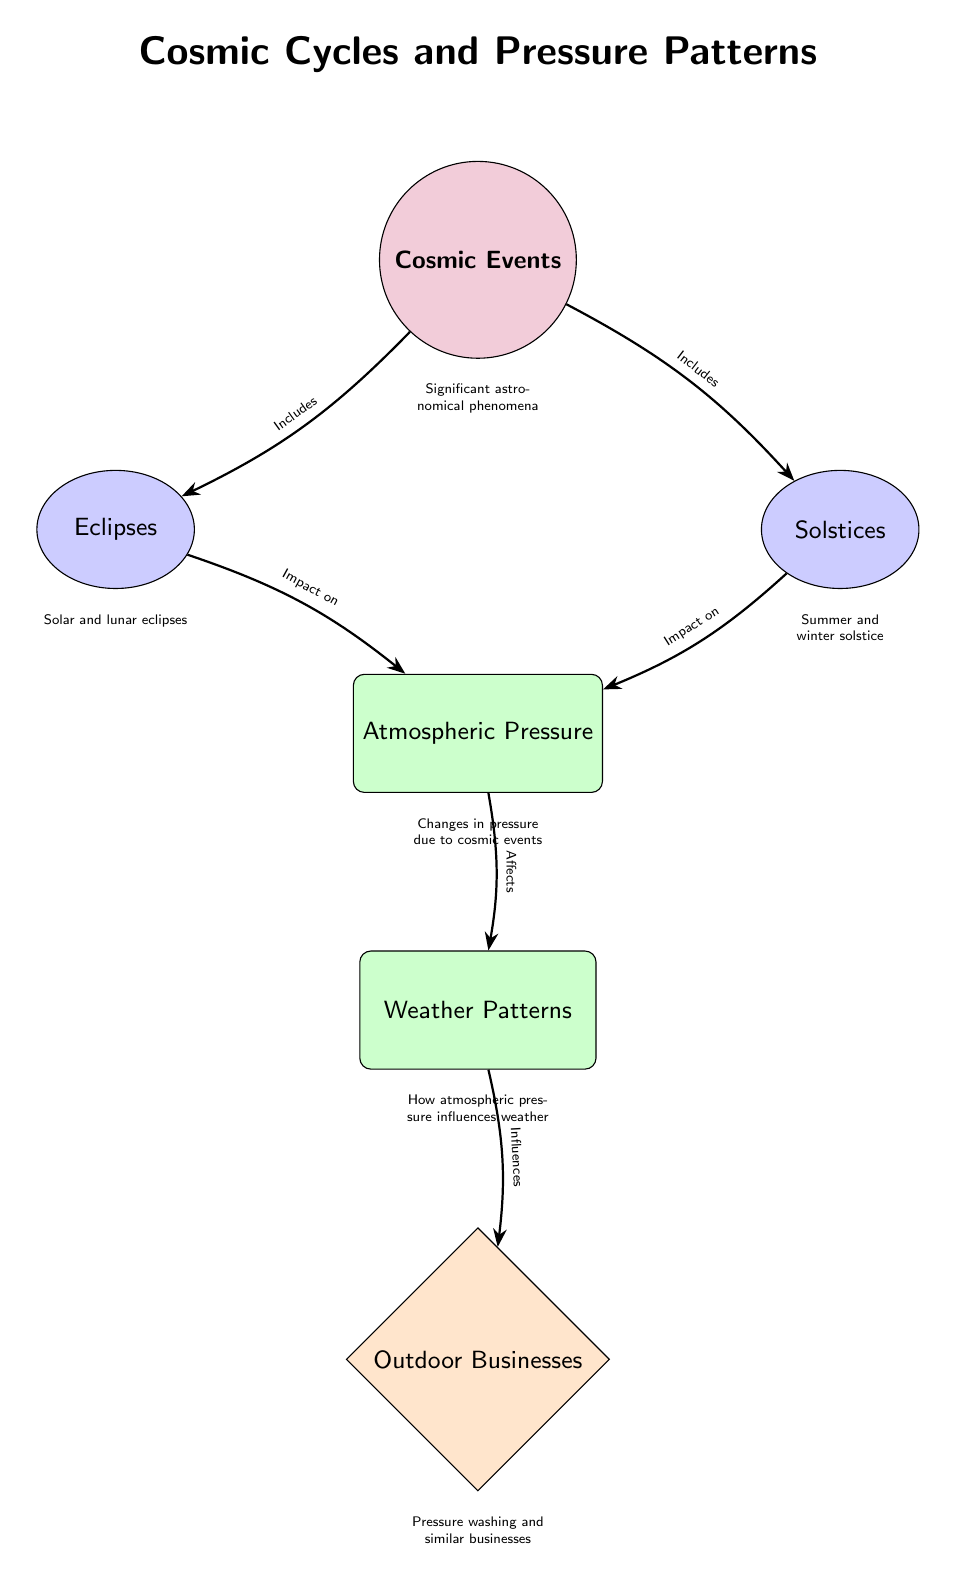What are the two types of cosmic events shown in the diagram? The diagram lists two types of cosmic events: eclipses and solstices. These events are represented as nodes directly connected to the main 'Cosmic Events' node.
Answer: Eclipses and Solstices How many types of effects are influenced by cosmic events? The diagram shows two types of effects that are influenced by cosmic events: atmospheric pressure and weather patterns. These effects are shown as nodes below 'Cosmic Events' and are connected in a sequence.
Answer: Two What do solar and lunar eclipses impact? In the diagram, solar and lunar eclipses are shown to impact atmospheric pressure, as indicated by the arrow pointing from 'Eclipses' to 'Atmospheric Pressure'.
Answer: Atmospheric Pressure What is the connection between atmospheric pressure and weather patterns? The diagram indicates that atmospheric pressure affects weather patterns, as shown by the arrow connecting 'Atmospheric Pressure' to 'Weather Patterns'. This implies a direct influence in the sequence of effects.
Answer: Affects How does weather influence outdoor businesses? According to the diagram, weather patterns influence outdoor businesses, as indicated by the connection from 'Weather Patterns' to 'Outdoor Businesses'. This suggests that changes in weather can impact the operations of such businesses.
Answer: Influences What is the primary focus of the diagram? The primary focus of the diagram is to explain the relationship between cosmic events and their effects on Earth, particularly atmospheric pressure and its impact on weather patterns for outdoor businesses. This focus is framed in the title and supported by the flow of the diagram.
Answer: Cosmic Cycles and Pressure Patterns What shapes are used to represent cosmic events in the diagram? The diagram uses circles filled with purple to represent cosmic events. The shape style for these nodes is defined in the diagram's code as 'cosmic'.
Answer: Circle How many edges are there from 'Cosmic Events' to its components? The diagram shows two edges extending from the 'Cosmic Events' node to 'Eclipses' and 'Solstices', indicating two connections in total. Each connection is an arrow representing the inclusion of these events.
Answer: Two 